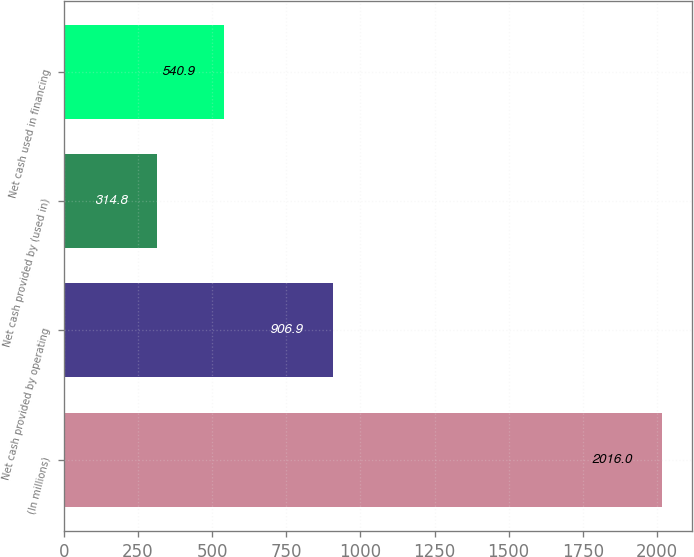Convert chart. <chart><loc_0><loc_0><loc_500><loc_500><bar_chart><fcel>(In millions)<fcel>Net cash provided by operating<fcel>Net cash provided by (used in)<fcel>Net cash used in financing<nl><fcel>2016<fcel>906.9<fcel>314.8<fcel>540.9<nl></chart> 